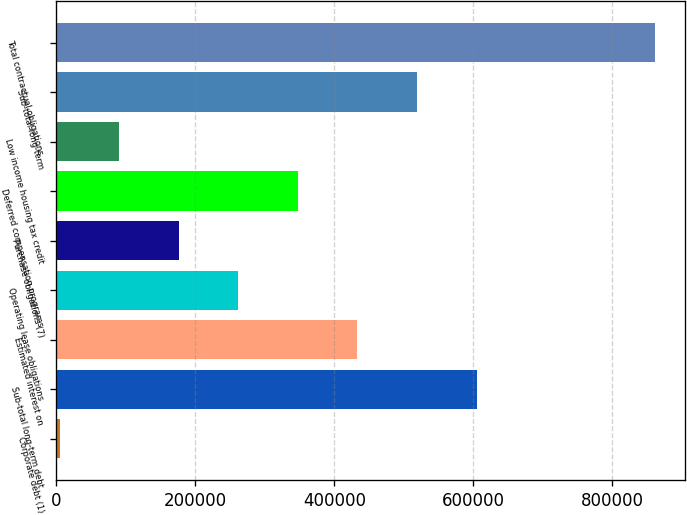Convert chart. <chart><loc_0><loc_0><loc_500><loc_500><bar_chart><fcel>Corporate debt (1)<fcel>Sub-total long-term debt<fcel>Estimated interest on<fcel>Operating lease obligations<fcel>Purchase obligations (7)<fcel>Deferred compensation programs<fcel>Low income housing tax credit<fcel>Sub-total long-term<fcel>Total contractual obligations<nl><fcel>4578<fcel>604736<fcel>433262<fcel>261788<fcel>176052<fcel>347525<fcel>90314.8<fcel>518999<fcel>861946<nl></chart> 